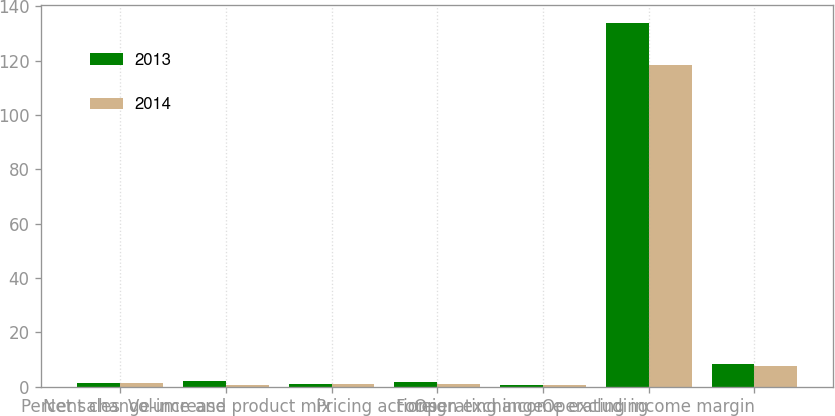<chart> <loc_0><loc_0><loc_500><loc_500><stacked_bar_chart><ecel><fcel>Net sales<fcel>Percent change-increase<fcel>Volume and product mix<fcel>Pricing actions<fcel>Foreign exchange<fcel>Operating income excluding<fcel>Operating income margin<nl><fcel>2013<fcel>1.5<fcel>2<fcel>0.9<fcel>1.8<fcel>0.7<fcel>133.9<fcel>8.3<nl><fcel>2014<fcel>1.5<fcel>0.8<fcel>1.2<fcel>1.2<fcel>0.8<fcel>118.5<fcel>7.5<nl></chart> 